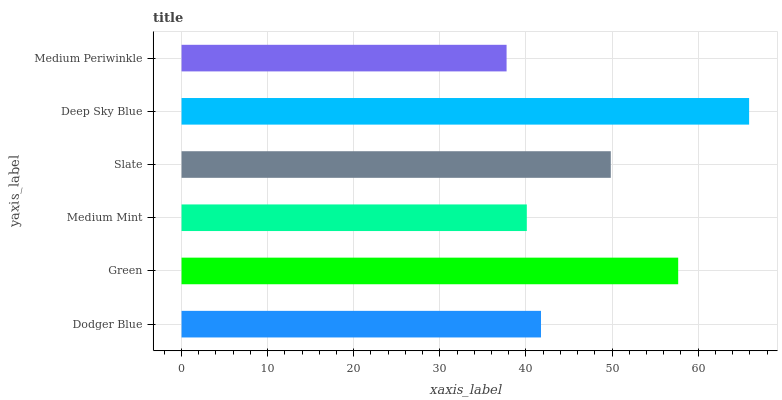Is Medium Periwinkle the minimum?
Answer yes or no. Yes. Is Deep Sky Blue the maximum?
Answer yes or no. Yes. Is Green the minimum?
Answer yes or no. No. Is Green the maximum?
Answer yes or no. No. Is Green greater than Dodger Blue?
Answer yes or no. Yes. Is Dodger Blue less than Green?
Answer yes or no. Yes. Is Dodger Blue greater than Green?
Answer yes or no. No. Is Green less than Dodger Blue?
Answer yes or no. No. Is Slate the high median?
Answer yes or no. Yes. Is Dodger Blue the low median?
Answer yes or no. Yes. Is Medium Periwinkle the high median?
Answer yes or no. No. Is Medium Mint the low median?
Answer yes or no. No. 